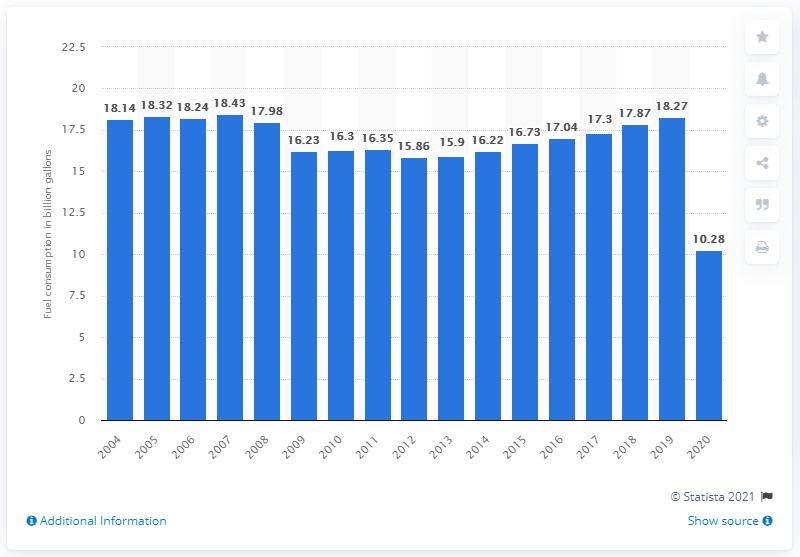Give some essential details in this illustration. In 2007, U.S. airlines consumed the highest amount of fuel at 18.27. In 2020, U.S. airlines consumed a significant amount of fuel due to the global coronavirus pandemic, amounting to 10.28 billion liters. In 2008, the United States economy underwent a recession. 